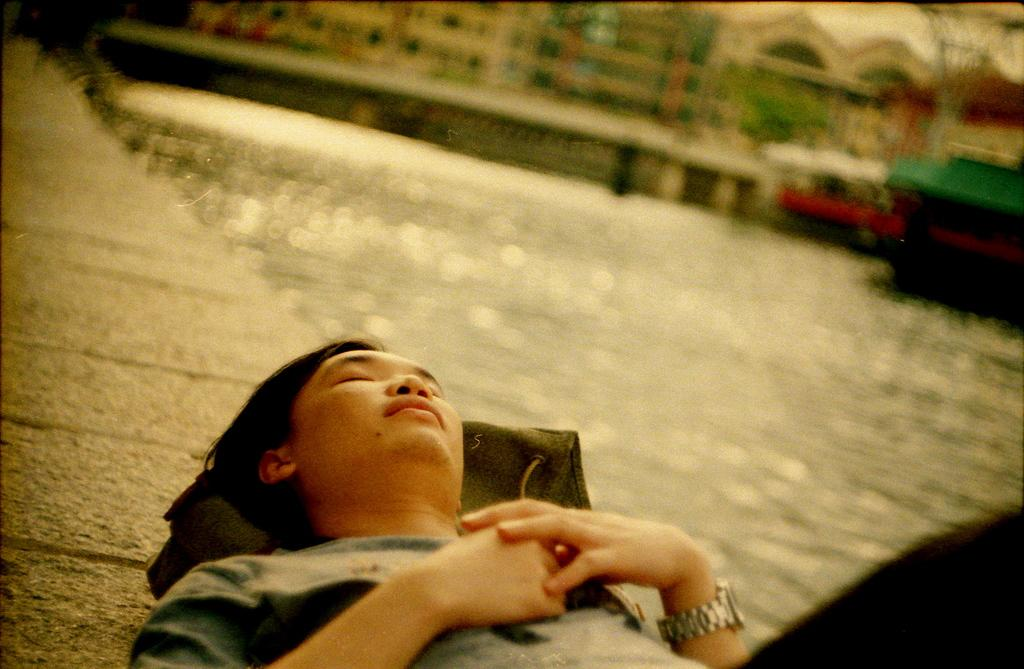What is the person in the image doing? The person is lying on the wall at the bottom of the image. What can be seen in the distance in the image? There are buildings in the background of the image. What natural element is visible in the image? There is water visible in the image. Where is the queen sitting in the image? There is no queen present in the image. What type of feather can be seen floating on the water in the image? There are no feathers visible in the image. 